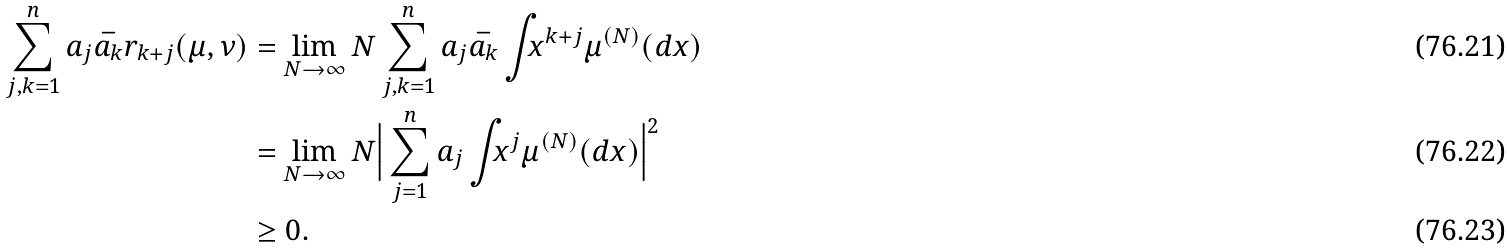<formula> <loc_0><loc_0><loc_500><loc_500>\sum _ { j , k = 1 } ^ { n } a _ { j } \bar { a _ { k } } r _ { k + j } ( \mu , \nu ) & = \lim _ { N \to \infty } N \sum _ { j , k = 1 } ^ { n } a _ { j } \bar { a _ { k } } \int _ { \real } x ^ { k + j } \mu ^ { ( N ) } ( d x ) \\ & = \lim _ { N \to \infty } N \Big { | } \sum _ { j = 1 } ^ { n } a _ { j } \int _ { \real } x ^ { j } \mu ^ { ( N ) } ( d x ) \Big { | } ^ { 2 } \\ & \geq 0 .</formula> 